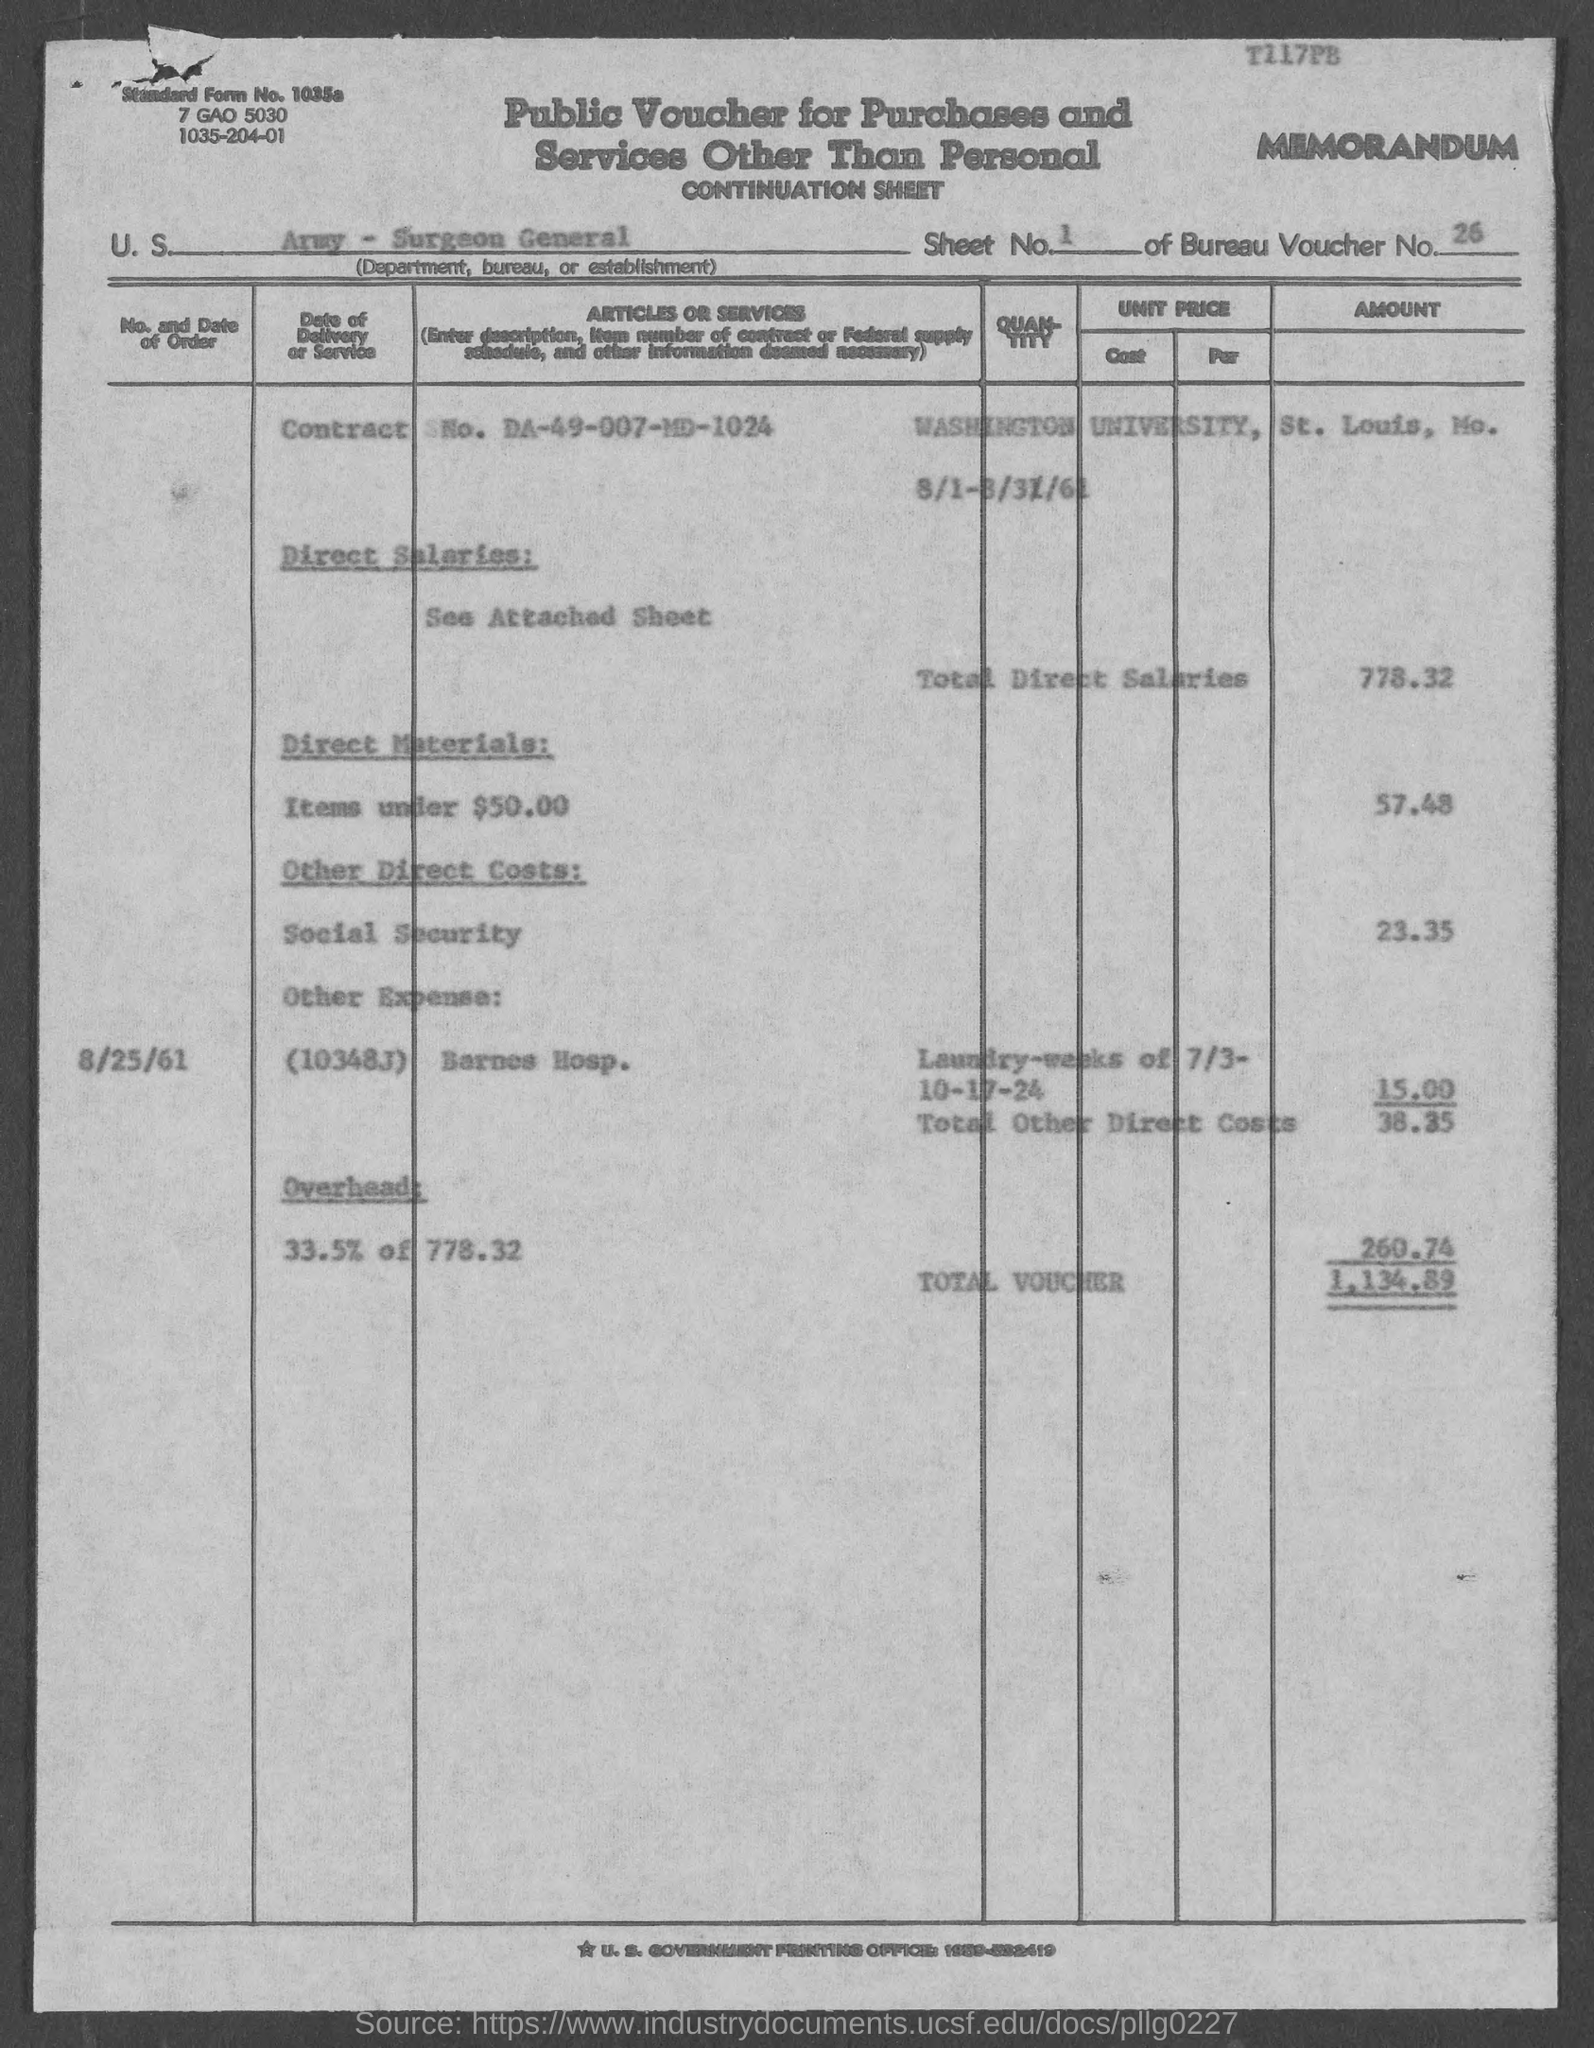What number is given in the top-right corner?
Your answer should be very brief. T117PB. What is the bureau voucher number?
Keep it short and to the point. 26. How much is the total voucher amount?
Your answer should be very brief. 1134.89. Under what sub heading  'See Attached sheet' comes?
Make the answer very short. Direct Salaries. What is the cost of direct materials?
Make the answer very short. 57.48. What is given in the form against the point U. S ?
Give a very brief answer. Army - Surgeon General. 